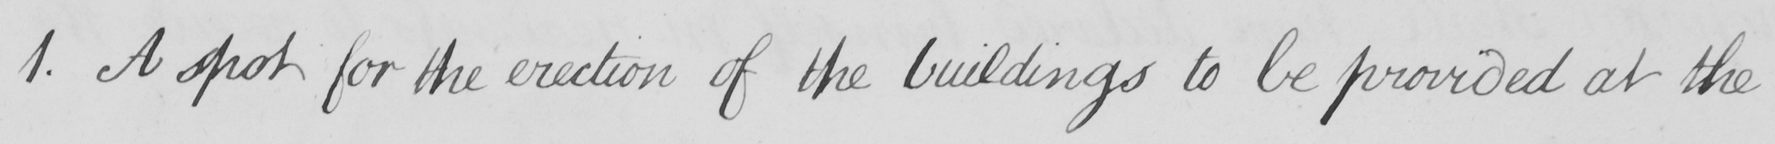What is written in this line of handwriting? 1 . A spot for the erection of the building to be provided at the 